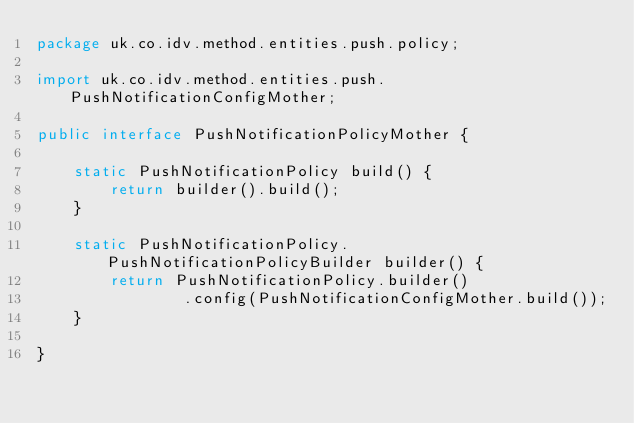Convert code to text. <code><loc_0><loc_0><loc_500><loc_500><_Java_>package uk.co.idv.method.entities.push.policy;

import uk.co.idv.method.entities.push.PushNotificationConfigMother;

public interface PushNotificationPolicyMother {

    static PushNotificationPolicy build() {
        return builder().build();
    }

    static PushNotificationPolicy.PushNotificationPolicyBuilder builder() {
        return PushNotificationPolicy.builder()
                .config(PushNotificationConfigMother.build());
    }

}
</code> 